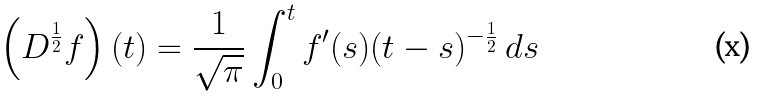<formula> <loc_0><loc_0><loc_500><loc_500>\left ( D ^ { \frac { 1 } { 2 } } f \right ) ( t ) = \frac { 1 } { \sqrt { \pi } } \int _ { 0 } ^ { t } f ^ { \prime } ( s ) ( t - s ) ^ { - \frac { 1 } { 2 } } \, d s</formula> 